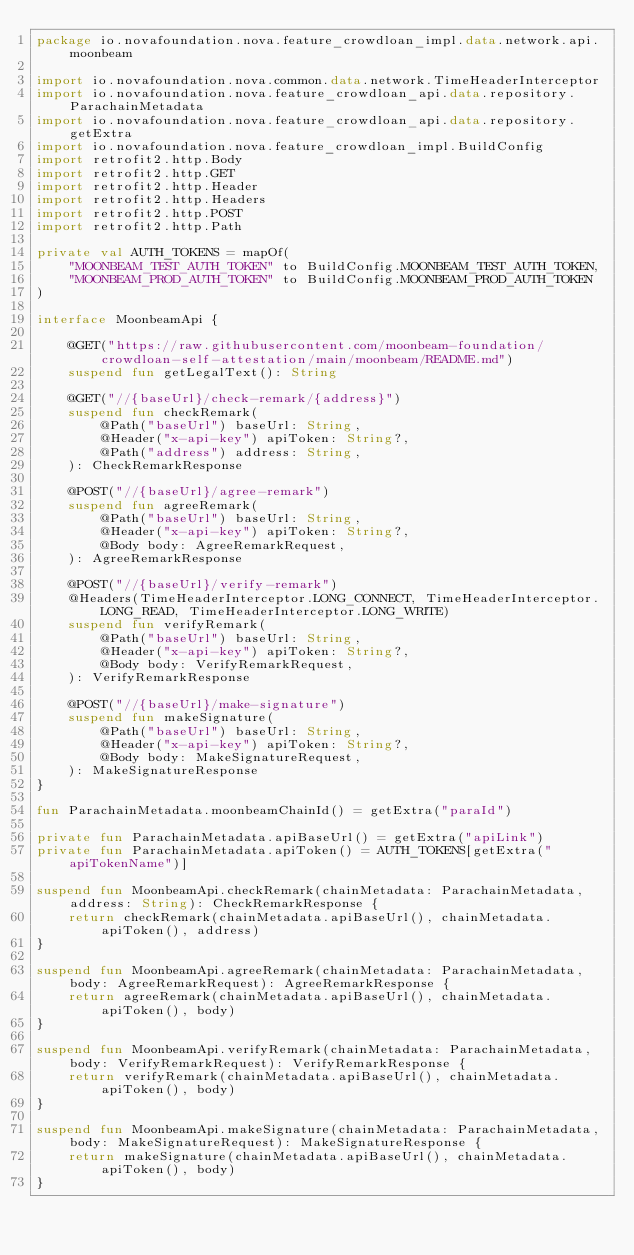Convert code to text. <code><loc_0><loc_0><loc_500><loc_500><_Kotlin_>package io.novafoundation.nova.feature_crowdloan_impl.data.network.api.moonbeam

import io.novafoundation.nova.common.data.network.TimeHeaderInterceptor
import io.novafoundation.nova.feature_crowdloan_api.data.repository.ParachainMetadata
import io.novafoundation.nova.feature_crowdloan_api.data.repository.getExtra
import io.novafoundation.nova.feature_crowdloan_impl.BuildConfig
import retrofit2.http.Body
import retrofit2.http.GET
import retrofit2.http.Header
import retrofit2.http.Headers
import retrofit2.http.POST
import retrofit2.http.Path

private val AUTH_TOKENS = mapOf(
    "MOONBEAM_TEST_AUTH_TOKEN" to BuildConfig.MOONBEAM_TEST_AUTH_TOKEN,
    "MOONBEAM_PROD_AUTH_TOKEN" to BuildConfig.MOONBEAM_PROD_AUTH_TOKEN
)

interface MoonbeamApi {

    @GET("https://raw.githubusercontent.com/moonbeam-foundation/crowdloan-self-attestation/main/moonbeam/README.md")
    suspend fun getLegalText(): String

    @GET("//{baseUrl}/check-remark/{address}")
    suspend fun checkRemark(
        @Path("baseUrl") baseUrl: String,
        @Header("x-api-key") apiToken: String?,
        @Path("address") address: String,
    ): CheckRemarkResponse

    @POST("//{baseUrl}/agree-remark")
    suspend fun agreeRemark(
        @Path("baseUrl") baseUrl: String,
        @Header("x-api-key") apiToken: String?,
        @Body body: AgreeRemarkRequest,
    ): AgreeRemarkResponse

    @POST("//{baseUrl}/verify-remark")
    @Headers(TimeHeaderInterceptor.LONG_CONNECT, TimeHeaderInterceptor.LONG_READ, TimeHeaderInterceptor.LONG_WRITE)
    suspend fun verifyRemark(
        @Path("baseUrl") baseUrl: String,
        @Header("x-api-key") apiToken: String?,
        @Body body: VerifyRemarkRequest,
    ): VerifyRemarkResponse

    @POST("//{baseUrl}/make-signature")
    suspend fun makeSignature(
        @Path("baseUrl") baseUrl: String,
        @Header("x-api-key") apiToken: String?,
        @Body body: MakeSignatureRequest,
    ): MakeSignatureResponse
}

fun ParachainMetadata.moonbeamChainId() = getExtra("paraId")

private fun ParachainMetadata.apiBaseUrl() = getExtra("apiLink")
private fun ParachainMetadata.apiToken() = AUTH_TOKENS[getExtra("apiTokenName")]

suspend fun MoonbeamApi.checkRemark(chainMetadata: ParachainMetadata, address: String): CheckRemarkResponse {
    return checkRemark(chainMetadata.apiBaseUrl(), chainMetadata.apiToken(), address)
}

suspend fun MoonbeamApi.agreeRemark(chainMetadata: ParachainMetadata, body: AgreeRemarkRequest): AgreeRemarkResponse {
    return agreeRemark(chainMetadata.apiBaseUrl(), chainMetadata.apiToken(), body)
}

suspend fun MoonbeamApi.verifyRemark(chainMetadata: ParachainMetadata, body: VerifyRemarkRequest): VerifyRemarkResponse {
    return verifyRemark(chainMetadata.apiBaseUrl(), chainMetadata.apiToken(), body)
}

suspend fun MoonbeamApi.makeSignature(chainMetadata: ParachainMetadata, body: MakeSignatureRequest): MakeSignatureResponse {
    return makeSignature(chainMetadata.apiBaseUrl(), chainMetadata.apiToken(), body)
}
</code> 